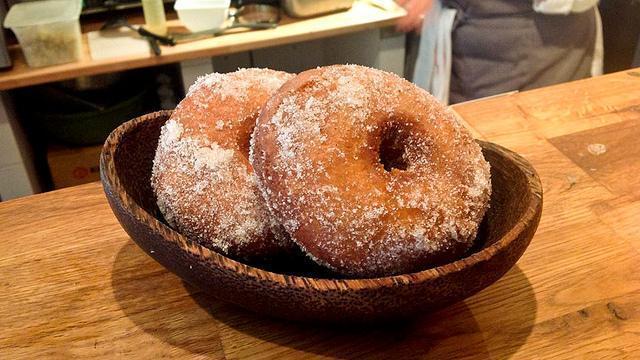How many people are in the picture?
Give a very brief answer. 1. How many clock faces are there?
Give a very brief answer. 0. 